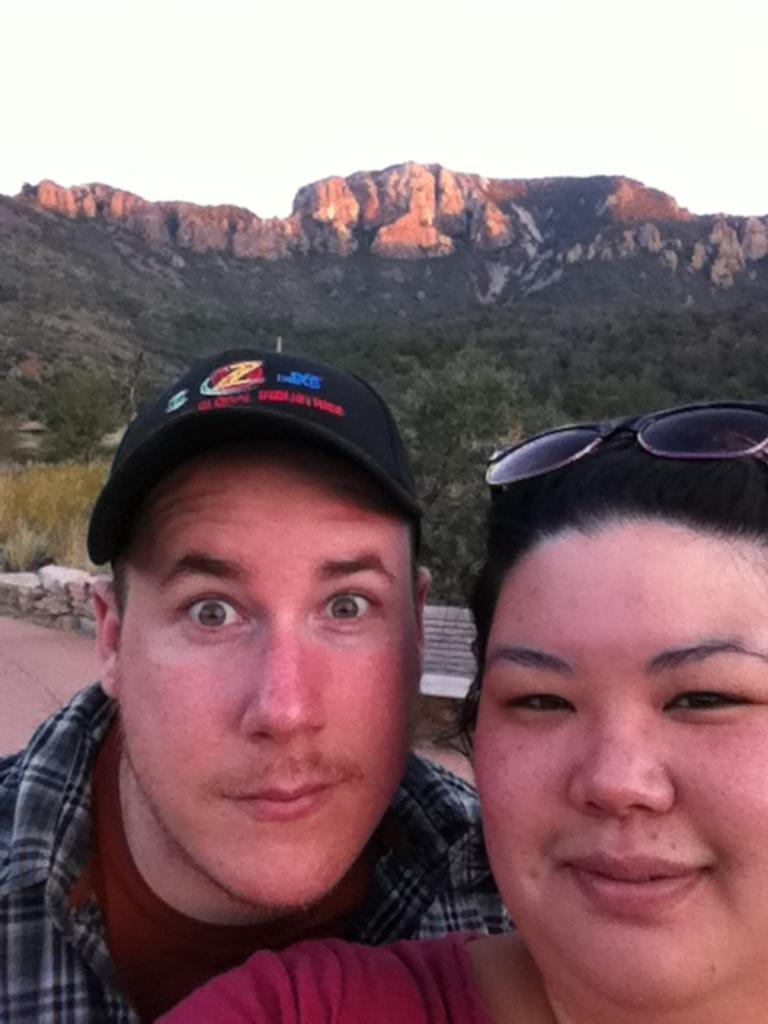How many people are in the image? There are two people in the image. What are the people wearing? The people are wearing different color dresses. What can be seen in the background of the image? There are rocks, trees, mountains, and the sky visible in the background of the image. Reasoning: Let' Let's think step by step in order to produce the conversation. We start by identifying the number of people in the image, which is two. Then, we describe what they are wearing, noting that they have different color dresses. Finally, we describe the background of the image, which includes rocks, trees, mountains, and the sky. Absurd Question/Answer: What type of stretch can be seen in the image? There is no stretch present in the image. Is there a train visible in the image? No, there is no train present in the image. 